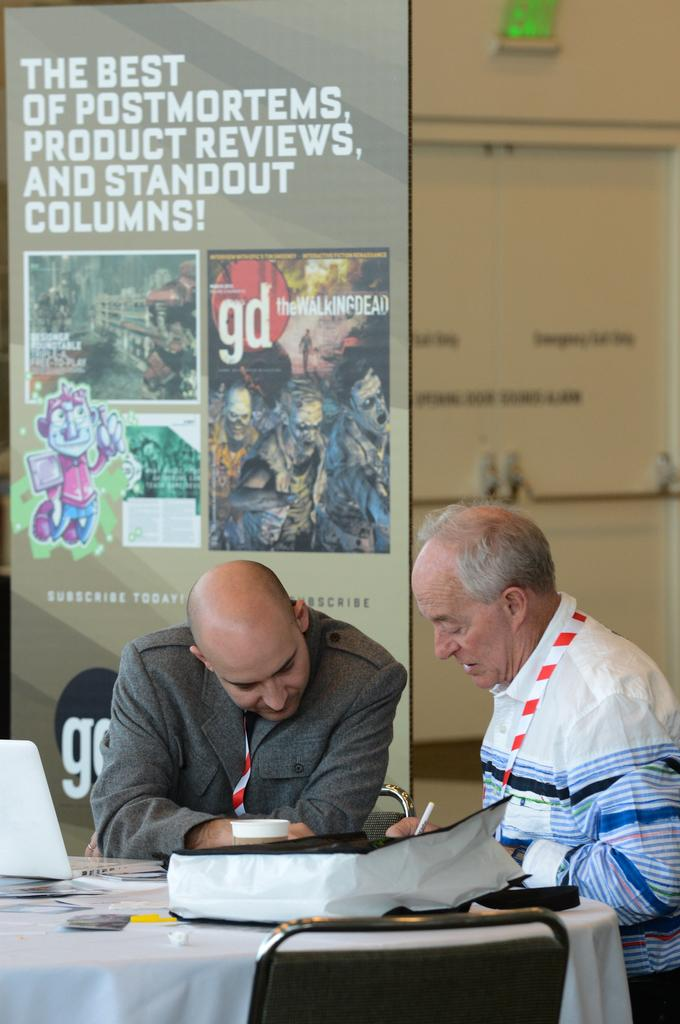<image>
Describe the image concisely. Two men sitting at a table with a walking dead poster behind them. 